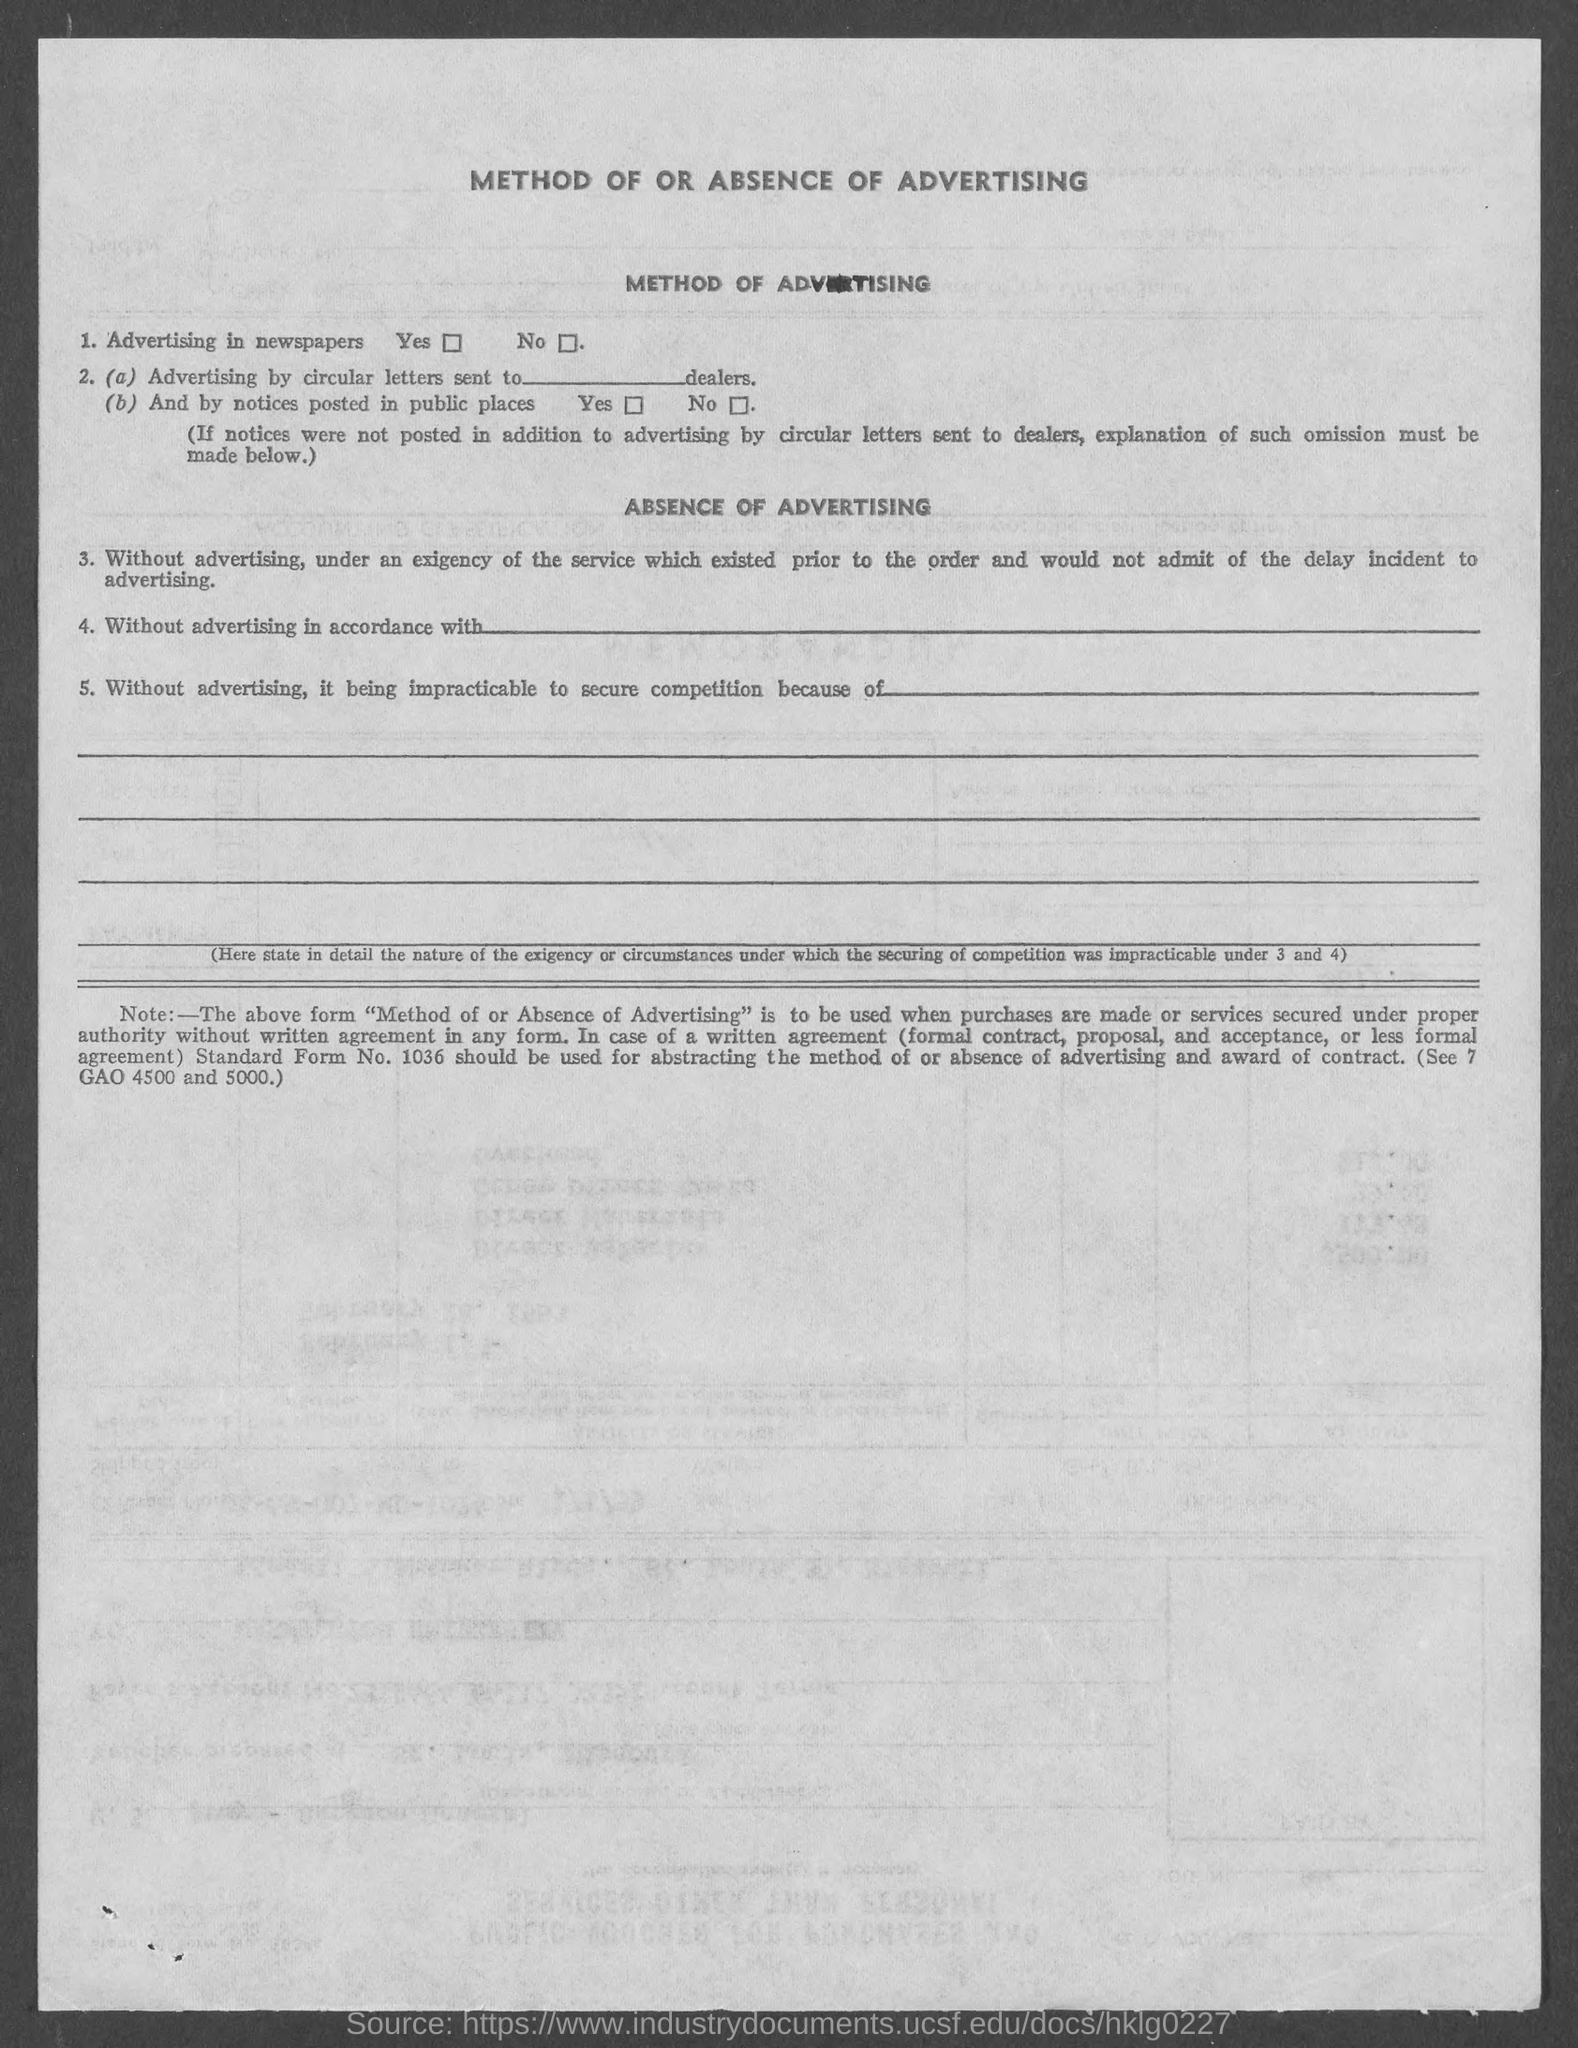What is the title of this document?
Offer a terse response. Method Of Or Absence Of Advertising. 